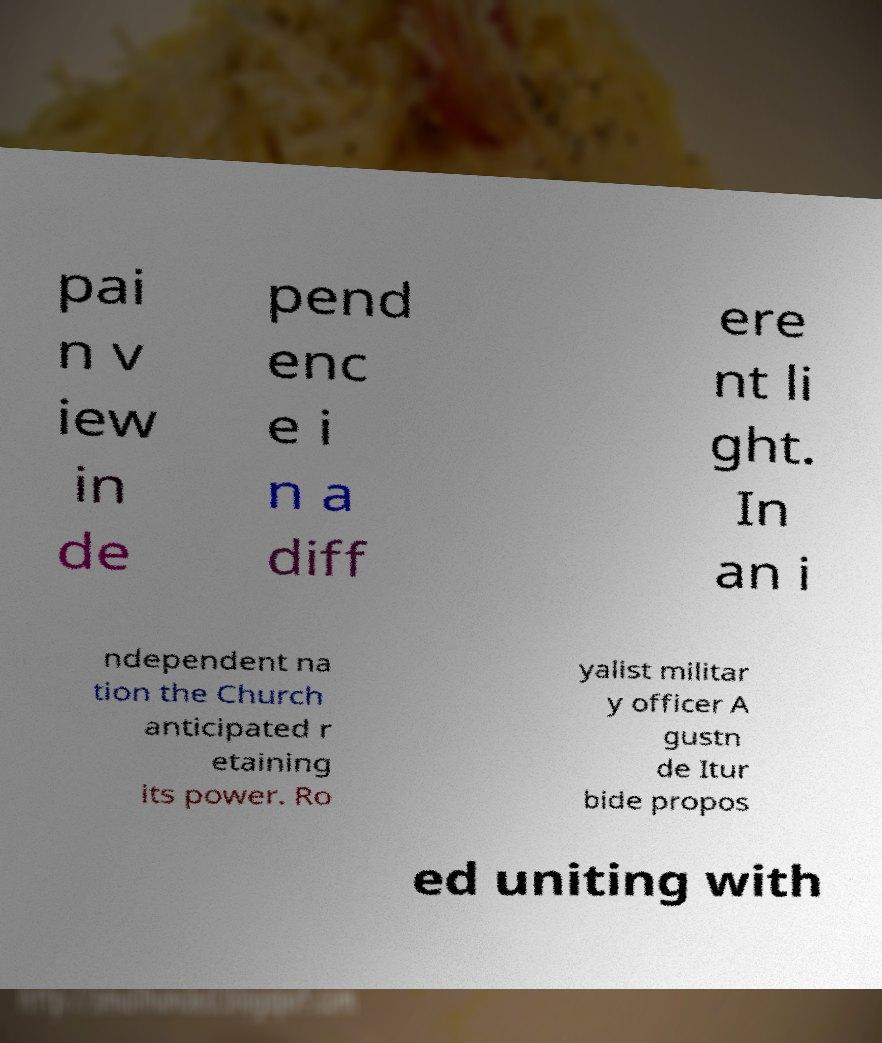Can you accurately transcribe the text from the provided image for me? pai n v iew in de pend enc e i n a diff ere nt li ght. In an i ndependent na tion the Church anticipated r etaining its power. Ro yalist militar y officer A gustn de Itur bide propos ed uniting with 